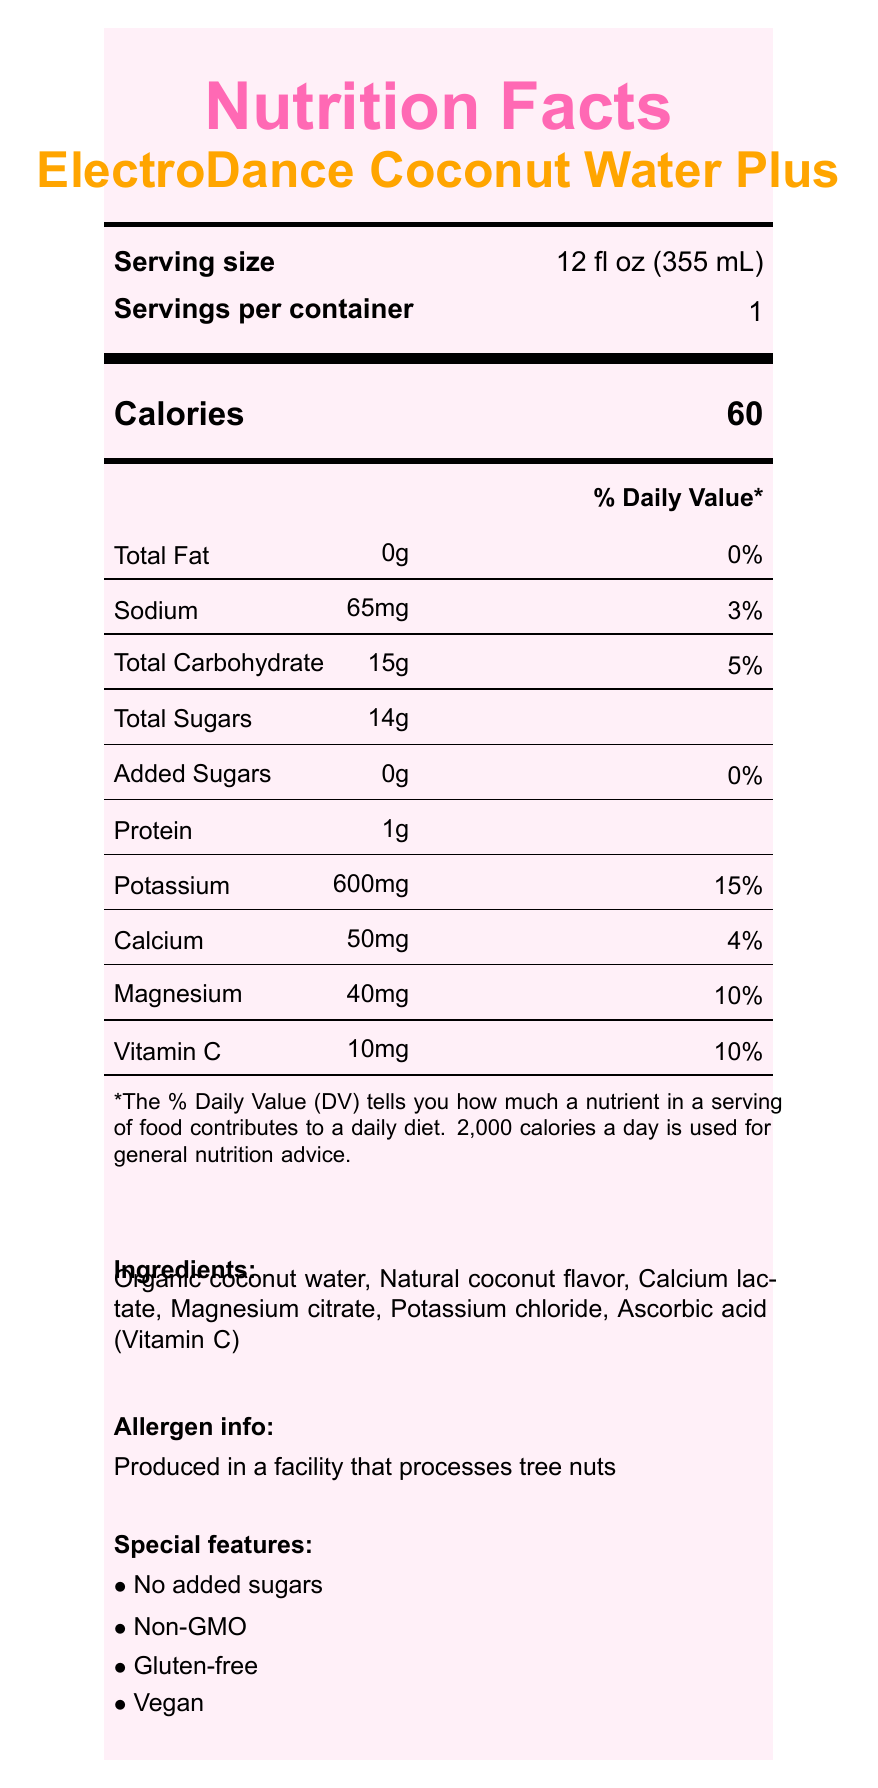what is the serving size of ElectroDance Coconut Water Plus? The serving size information is listed in the Serving size section of the nutrition label.
Answer: 12 fl oz (355 mL) how many calories are in one serving? The calorie count is displayed prominently in the Calories section of the nutrition label.
Answer: 60 what percentage of the daily value of potassium does one serving of this product provide? The percentage of daily value for potassium is listed as 15% in the nutrient table of the nutrition label.
Answer: 15% how much protein is in one serving? The amount of protein per serving is listed as 1g in the nutrient table.
Answer: 1g does ElectroDance Coconut Water Plus contain any added sugars? The nutrient table states that the amount of added sugars is 0g and the daily value is 0%.
Answer: No which of the following is not an ingredient in ElectroDance Coconut Water Plus? A. Organic coconut water B. Calcium lactate C. Sodium chloride D. Magnesium citrate The ingredients list includes Organic coconut water, Natural coconut flavor, Calcium lactate, Magnesium citrate, Potassium chloride, and Ascorbic acid (Vitamin C). Sodium chloride is not listed.
Answer: C. Sodium chloride what is the main function of ElectroDance Coconut Water Plus for dancers? A. Replenishes electrolytes B. Provides caffeine boost C. High calorie content D. Includes artificial stimulants According to the dancer benefits section, the product replenishes electrolytes lost during intense dance performances. The other options are incorrect as the label states "No caffeine or artificial stimulants" and it is a "Low calorie option".
Answer: A. Replenishes electrolytes is ElectroDance Coconut Water Plus gluten-free? The special features section mentions that the product is gluten-free.
Answer: Yes how many milligrams of magnesium does one serving contain? The amount of magnesium per serving is listed as 40 mg in the nutrient table.
Answer: 40mg summarize the main idea of the document. The document includes detailed information about serving size, calories, various nutrients, and percentages of daily values. It also lists the ingredients, mentions allergen information, and notes special features like being non-GMO, gluten-free, and vegan. Specific benefits for dancers are also outlined.
Answer: The document provides the nutrition facts label for ElectroDance Coconut Water Plus, highlighting its nutrient content, ingredients, allergen info, special features, and benefits for dancers. who is the distributor of this product? The distributor information is found at the bottom of the nutrition label.
Answer: DanceFuel Nutrition, LLC how can one contact the product's manufacturer? The label does not provide contact information for the manufacturer, only the name (GrooveHydrate Beverages, Inc.).
Answer: Not enough information what type of packaging is used for ElectroDance Coconut Water Plus? The packaging information is mentioned at the bottom of the nutrition label.
Answer: BPA-free, recyclable plastic bottle 